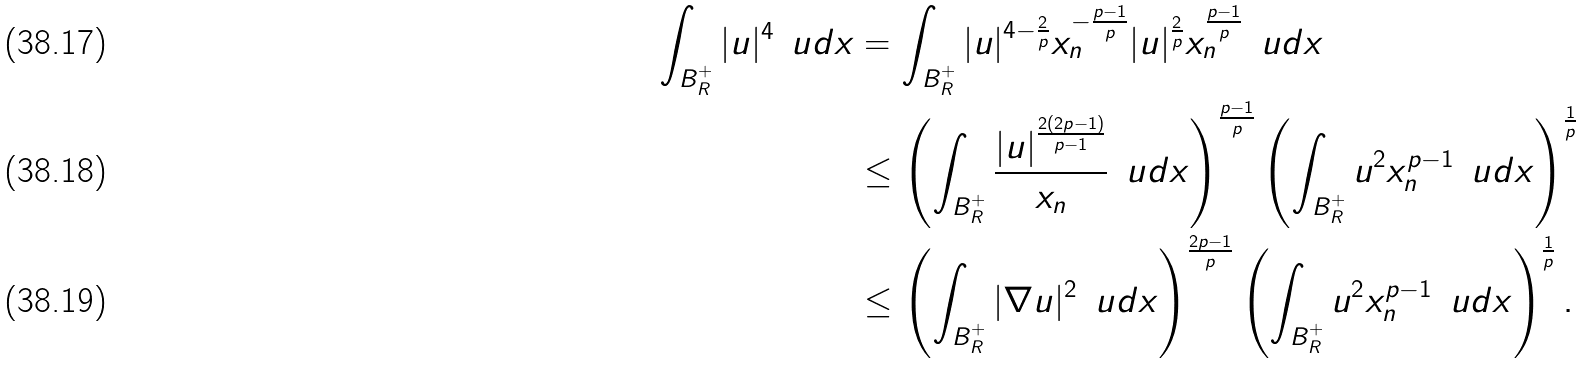<formula> <loc_0><loc_0><loc_500><loc_500>\int _ { B _ { R } ^ { + } } | u | ^ { 4 } \, \ u d x & = \int _ { B _ { R } ^ { + } } | u | ^ { 4 - \frac { 2 } { p } } x _ { n } ^ { - \frac { p - 1 } { p } } | u | ^ { \frac { 2 } { p } } x _ { n } ^ { \frac { p - 1 } { p } } \, \ u d x \\ & \leq \left ( \int _ { B _ { R } ^ { + } } \frac { | u | ^ { \frac { 2 ( 2 p - 1 ) } { p - 1 } } } { x _ { n } } \, \ u d x \right ) ^ { \frac { p - 1 } { p } } \left ( \int _ { B _ { R } ^ { + } } u ^ { 2 } x _ { n } ^ { p - 1 } \, \ u d x \right ) ^ { \frac { 1 } { p } } \\ & \leq \left ( \int _ { B _ { R } ^ { + } } | \nabla u | ^ { 2 } \, \ u d x \right ) ^ { \frac { 2 p - 1 } { p } } \left ( \int _ { B _ { R } ^ { + } } u ^ { 2 } x _ { n } ^ { p - 1 } \, \ u d x \right ) ^ { \frac { 1 } { p } } .</formula> 